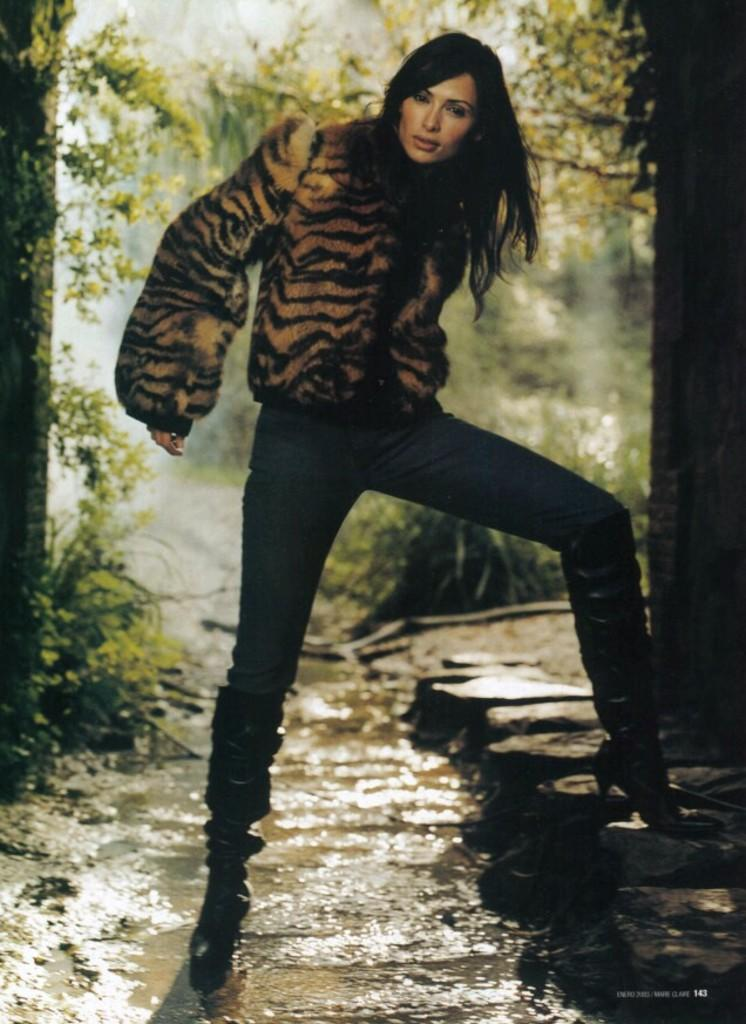What is the main subject of the image? There is a woman standing in the image. What can be seen in the background of the image? There are trees in the background of the image. What else is visible in the image besides the woman? Water is visible in the image. What type of voice can be heard coming from the woman in the image? There is no indication of any sound or voice in the image, so it cannot be determined from the image. 